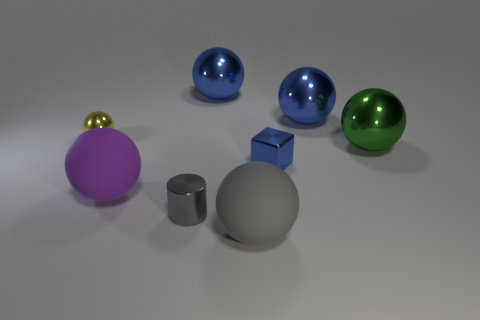Subtract all small metallic spheres. How many spheres are left? 5 Subtract all red cubes. How many blue balls are left? 2 Add 1 small shiny spheres. How many objects exist? 9 Subtract 2 spheres. How many spheres are left? 4 Subtract all blue spheres. How many spheres are left? 4 Subtract all purple spheres. Subtract all red cubes. How many spheres are left? 5 Add 3 yellow balls. How many yellow balls exist? 4 Subtract 0 brown spheres. How many objects are left? 8 Subtract all spheres. How many objects are left? 2 Subtract all small matte spheres. Subtract all metal balls. How many objects are left? 4 